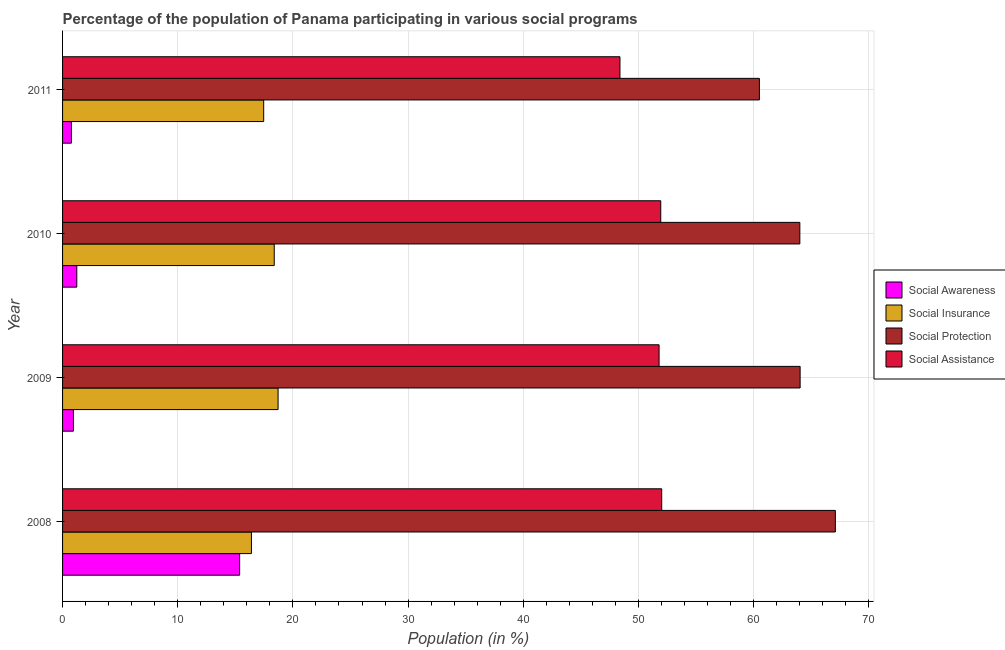How many different coloured bars are there?
Your answer should be very brief. 4. How many groups of bars are there?
Provide a succinct answer. 4. Are the number of bars per tick equal to the number of legend labels?
Provide a short and direct response. Yes. How many bars are there on the 3rd tick from the top?
Your answer should be compact. 4. How many bars are there on the 3rd tick from the bottom?
Provide a short and direct response. 4. In how many cases, is the number of bars for a given year not equal to the number of legend labels?
Ensure brevity in your answer.  0. What is the participation of population in social assistance programs in 2008?
Give a very brief answer. 52.02. Across all years, what is the maximum participation of population in social assistance programs?
Give a very brief answer. 52.02. Across all years, what is the minimum participation of population in social insurance programs?
Your answer should be very brief. 16.4. In which year was the participation of population in social insurance programs maximum?
Provide a short and direct response. 2009. In which year was the participation of population in social insurance programs minimum?
Offer a very short reply. 2008. What is the total participation of population in social awareness programs in the graph?
Your response must be concise. 18.32. What is the difference between the participation of population in social insurance programs in 2009 and that in 2011?
Offer a very short reply. 1.25. What is the difference between the participation of population in social awareness programs in 2009 and the participation of population in social assistance programs in 2011?
Offer a terse response. -47.45. What is the average participation of population in social insurance programs per year?
Ensure brevity in your answer.  17.74. In the year 2009, what is the difference between the participation of population in social insurance programs and participation of population in social assistance programs?
Your answer should be very brief. -33.08. In how many years, is the participation of population in social protection programs greater than 24 %?
Offer a very short reply. 4. Is the difference between the participation of population in social awareness programs in 2009 and 2011 greater than the difference between the participation of population in social protection programs in 2009 and 2011?
Offer a terse response. No. What is the difference between the highest and the second highest participation of population in social protection programs?
Your answer should be very brief. 3.06. What is the difference between the highest and the lowest participation of population in social assistance programs?
Your answer should be very brief. 3.62. In how many years, is the participation of population in social assistance programs greater than the average participation of population in social assistance programs taken over all years?
Offer a very short reply. 3. Is the sum of the participation of population in social awareness programs in 2008 and 2009 greater than the maximum participation of population in social insurance programs across all years?
Offer a very short reply. No. What does the 1st bar from the top in 2010 represents?
Provide a short and direct response. Social Assistance. What does the 3rd bar from the bottom in 2009 represents?
Your response must be concise. Social Protection. Are the values on the major ticks of X-axis written in scientific E-notation?
Make the answer very short. No. Does the graph contain any zero values?
Your answer should be very brief. No. Where does the legend appear in the graph?
Provide a succinct answer. Center right. How many legend labels are there?
Your answer should be compact. 4. What is the title of the graph?
Your response must be concise. Percentage of the population of Panama participating in various social programs . What is the label or title of the Y-axis?
Your answer should be compact. Year. What is the Population (in %) of Social Awareness in 2008?
Your answer should be very brief. 15.38. What is the Population (in %) of Social Insurance in 2008?
Your answer should be very brief. 16.4. What is the Population (in %) of Social Protection in 2008?
Keep it short and to the point. 67.1. What is the Population (in %) in Social Assistance in 2008?
Your answer should be compact. 52.02. What is the Population (in %) of Social Awareness in 2009?
Keep it short and to the point. 0.94. What is the Population (in %) in Social Insurance in 2009?
Offer a very short reply. 18.71. What is the Population (in %) in Social Protection in 2009?
Offer a very short reply. 64.04. What is the Population (in %) in Social Assistance in 2009?
Offer a terse response. 51.79. What is the Population (in %) in Social Awareness in 2010?
Your answer should be very brief. 1.24. What is the Population (in %) in Social Insurance in 2010?
Offer a very short reply. 18.38. What is the Population (in %) in Social Protection in 2010?
Ensure brevity in your answer.  64.02. What is the Population (in %) in Social Assistance in 2010?
Your response must be concise. 51.94. What is the Population (in %) in Social Awareness in 2011?
Keep it short and to the point. 0.77. What is the Population (in %) of Social Insurance in 2011?
Ensure brevity in your answer.  17.46. What is the Population (in %) in Social Protection in 2011?
Provide a short and direct response. 60.5. What is the Population (in %) of Social Assistance in 2011?
Provide a short and direct response. 48.4. Across all years, what is the maximum Population (in %) of Social Awareness?
Keep it short and to the point. 15.38. Across all years, what is the maximum Population (in %) of Social Insurance?
Your answer should be very brief. 18.71. Across all years, what is the maximum Population (in %) of Social Protection?
Your answer should be compact. 67.1. Across all years, what is the maximum Population (in %) of Social Assistance?
Your response must be concise. 52.02. Across all years, what is the minimum Population (in %) of Social Awareness?
Your answer should be compact. 0.77. Across all years, what is the minimum Population (in %) of Social Insurance?
Offer a terse response. 16.4. Across all years, what is the minimum Population (in %) of Social Protection?
Make the answer very short. 60.5. Across all years, what is the minimum Population (in %) in Social Assistance?
Offer a very short reply. 48.4. What is the total Population (in %) of Social Awareness in the graph?
Offer a very short reply. 18.32. What is the total Population (in %) in Social Insurance in the graph?
Give a very brief answer. 70.95. What is the total Population (in %) of Social Protection in the graph?
Keep it short and to the point. 255.66. What is the total Population (in %) in Social Assistance in the graph?
Make the answer very short. 204.15. What is the difference between the Population (in %) in Social Awareness in 2008 and that in 2009?
Make the answer very short. 14.43. What is the difference between the Population (in %) in Social Insurance in 2008 and that in 2009?
Ensure brevity in your answer.  -2.31. What is the difference between the Population (in %) of Social Protection in 2008 and that in 2009?
Offer a terse response. 3.06. What is the difference between the Population (in %) of Social Assistance in 2008 and that in 2009?
Make the answer very short. 0.23. What is the difference between the Population (in %) of Social Awareness in 2008 and that in 2010?
Your response must be concise. 14.14. What is the difference between the Population (in %) of Social Insurance in 2008 and that in 2010?
Offer a terse response. -1.98. What is the difference between the Population (in %) in Social Protection in 2008 and that in 2010?
Give a very brief answer. 3.08. What is the difference between the Population (in %) of Social Assistance in 2008 and that in 2010?
Keep it short and to the point. 0.08. What is the difference between the Population (in %) of Social Awareness in 2008 and that in 2011?
Offer a terse response. 14.61. What is the difference between the Population (in %) of Social Insurance in 2008 and that in 2011?
Offer a terse response. -1.06. What is the difference between the Population (in %) of Social Protection in 2008 and that in 2011?
Offer a terse response. 6.59. What is the difference between the Population (in %) in Social Assistance in 2008 and that in 2011?
Provide a short and direct response. 3.62. What is the difference between the Population (in %) of Social Awareness in 2009 and that in 2010?
Your response must be concise. -0.29. What is the difference between the Population (in %) in Social Insurance in 2009 and that in 2010?
Make the answer very short. 0.33. What is the difference between the Population (in %) in Social Protection in 2009 and that in 2010?
Your answer should be very brief. 0.02. What is the difference between the Population (in %) in Social Assistance in 2009 and that in 2010?
Give a very brief answer. -0.15. What is the difference between the Population (in %) of Social Awareness in 2009 and that in 2011?
Your response must be concise. 0.17. What is the difference between the Population (in %) in Social Insurance in 2009 and that in 2011?
Your answer should be compact. 1.25. What is the difference between the Population (in %) of Social Protection in 2009 and that in 2011?
Provide a short and direct response. 3.54. What is the difference between the Population (in %) in Social Assistance in 2009 and that in 2011?
Provide a succinct answer. 3.4. What is the difference between the Population (in %) in Social Awareness in 2010 and that in 2011?
Give a very brief answer. 0.47. What is the difference between the Population (in %) in Social Insurance in 2010 and that in 2011?
Keep it short and to the point. 0.92. What is the difference between the Population (in %) in Social Protection in 2010 and that in 2011?
Provide a short and direct response. 3.51. What is the difference between the Population (in %) in Social Assistance in 2010 and that in 2011?
Your answer should be very brief. 3.54. What is the difference between the Population (in %) of Social Awareness in 2008 and the Population (in %) of Social Insurance in 2009?
Your answer should be compact. -3.34. What is the difference between the Population (in %) in Social Awareness in 2008 and the Population (in %) in Social Protection in 2009?
Offer a terse response. -48.66. What is the difference between the Population (in %) in Social Awareness in 2008 and the Population (in %) in Social Assistance in 2009?
Keep it short and to the point. -36.42. What is the difference between the Population (in %) of Social Insurance in 2008 and the Population (in %) of Social Protection in 2009?
Your answer should be very brief. -47.64. What is the difference between the Population (in %) in Social Insurance in 2008 and the Population (in %) in Social Assistance in 2009?
Provide a short and direct response. -35.39. What is the difference between the Population (in %) in Social Protection in 2008 and the Population (in %) in Social Assistance in 2009?
Ensure brevity in your answer.  15.3. What is the difference between the Population (in %) in Social Awareness in 2008 and the Population (in %) in Social Insurance in 2010?
Give a very brief answer. -3. What is the difference between the Population (in %) in Social Awareness in 2008 and the Population (in %) in Social Protection in 2010?
Provide a short and direct response. -48.64. What is the difference between the Population (in %) of Social Awareness in 2008 and the Population (in %) of Social Assistance in 2010?
Your response must be concise. -36.56. What is the difference between the Population (in %) in Social Insurance in 2008 and the Population (in %) in Social Protection in 2010?
Provide a short and direct response. -47.62. What is the difference between the Population (in %) in Social Insurance in 2008 and the Population (in %) in Social Assistance in 2010?
Provide a succinct answer. -35.54. What is the difference between the Population (in %) in Social Protection in 2008 and the Population (in %) in Social Assistance in 2010?
Make the answer very short. 15.16. What is the difference between the Population (in %) in Social Awareness in 2008 and the Population (in %) in Social Insurance in 2011?
Your answer should be compact. -2.09. What is the difference between the Population (in %) in Social Awareness in 2008 and the Population (in %) in Social Protection in 2011?
Your response must be concise. -45.13. What is the difference between the Population (in %) of Social Awareness in 2008 and the Population (in %) of Social Assistance in 2011?
Keep it short and to the point. -33.02. What is the difference between the Population (in %) of Social Insurance in 2008 and the Population (in %) of Social Protection in 2011?
Offer a terse response. -44.1. What is the difference between the Population (in %) in Social Insurance in 2008 and the Population (in %) in Social Assistance in 2011?
Offer a very short reply. -32. What is the difference between the Population (in %) in Social Protection in 2008 and the Population (in %) in Social Assistance in 2011?
Provide a succinct answer. 18.7. What is the difference between the Population (in %) in Social Awareness in 2009 and the Population (in %) in Social Insurance in 2010?
Keep it short and to the point. -17.44. What is the difference between the Population (in %) in Social Awareness in 2009 and the Population (in %) in Social Protection in 2010?
Your response must be concise. -63.07. What is the difference between the Population (in %) of Social Awareness in 2009 and the Population (in %) of Social Assistance in 2010?
Ensure brevity in your answer.  -51. What is the difference between the Population (in %) in Social Insurance in 2009 and the Population (in %) in Social Protection in 2010?
Give a very brief answer. -45.3. What is the difference between the Population (in %) of Social Insurance in 2009 and the Population (in %) of Social Assistance in 2010?
Your answer should be compact. -33.23. What is the difference between the Population (in %) of Social Protection in 2009 and the Population (in %) of Social Assistance in 2010?
Your answer should be compact. 12.1. What is the difference between the Population (in %) in Social Awareness in 2009 and the Population (in %) in Social Insurance in 2011?
Provide a succinct answer. -16.52. What is the difference between the Population (in %) in Social Awareness in 2009 and the Population (in %) in Social Protection in 2011?
Your answer should be compact. -59.56. What is the difference between the Population (in %) in Social Awareness in 2009 and the Population (in %) in Social Assistance in 2011?
Offer a very short reply. -47.45. What is the difference between the Population (in %) in Social Insurance in 2009 and the Population (in %) in Social Protection in 2011?
Your answer should be compact. -41.79. What is the difference between the Population (in %) in Social Insurance in 2009 and the Population (in %) in Social Assistance in 2011?
Offer a very short reply. -29.68. What is the difference between the Population (in %) in Social Protection in 2009 and the Population (in %) in Social Assistance in 2011?
Provide a succinct answer. 15.64. What is the difference between the Population (in %) in Social Awareness in 2010 and the Population (in %) in Social Insurance in 2011?
Provide a succinct answer. -16.23. What is the difference between the Population (in %) in Social Awareness in 2010 and the Population (in %) in Social Protection in 2011?
Your answer should be compact. -59.27. What is the difference between the Population (in %) in Social Awareness in 2010 and the Population (in %) in Social Assistance in 2011?
Offer a very short reply. -47.16. What is the difference between the Population (in %) in Social Insurance in 2010 and the Population (in %) in Social Protection in 2011?
Provide a short and direct response. -42.12. What is the difference between the Population (in %) of Social Insurance in 2010 and the Population (in %) of Social Assistance in 2011?
Provide a succinct answer. -30.02. What is the difference between the Population (in %) in Social Protection in 2010 and the Population (in %) in Social Assistance in 2011?
Give a very brief answer. 15.62. What is the average Population (in %) in Social Awareness per year?
Your response must be concise. 4.58. What is the average Population (in %) in Social Insurance per year?
Give a very brief answer. 17.74. What is the average Population (in %) in Social Protection per year?
Provide a succinct answer. 63.91. What is the average Population (in %) in Social Assistance per year?
Offer a very short reply. 51.04. In the year 2008, what is the difference between the Population (in %) in Social Awareness and Population (in %) in Social Insurance?
Offer a terse response. -1.02. In the year 2008, what is the difference between the Population (in %) of Social Awareness and Population (in %) of Social Protection?
Your answer should be compact. -51.72. In the year 2008, what is the difference between the Population (in %) of Social Awareness and Population (in %) of Social Assistance?
Your response must be concise. -36.65. In the year 2008, what is the difference between the Population (in %) in Social Insurance and Population (in %) in Social Protection?
Your answer should be compact. -50.7. In the year 2008, what is the difference between the Population (in %) of Social Insurance and Population (in %) of Social Assistance?
Ensure brevity in your answer.  -35.62. In the year 2008, what is the difference between the Population (in %) in Social Protection and Population (in %) in Social Assistance?
Make the answer very short. 15.08. In the year 2009, what is the difference between the Population (in %) of Social Awareness and Population (in %) of Social Insurance?
Provide a short and direct response. -17.77. In the year 2009, what is the difference between the Population (in %) in Social Awareness and Population (in %) in Social Protection?
Provide a short and direct response. -63.1. In the year 2009, what is the difference between the Population (in %) of Social Awareness and Population (in %) of Social Assistance?
Your response must be concise. -50.85. In the year 2009, what is the difference between the Population (in %) in Social Insurance and Population (in %) in Social Protection?
Offer a very short reply. -45.33. In the year 2009, what is the difference between the Population (in %) in Social Insurance and Population (in %) in Social Assistance?
Make the answer very short. -33.08. In the year 2009, what is the difference between the Population (in %) of Social Protection and Population (in %) of Social Assistance?
Keep it short and to the point. 12.25. In the year 2010, what is the difference between the Population (in %) in Social Awareness and Population (in %) in Social Insurance?
Give a very brief answer. -17.14. In the year 2010, what is the difference between the Population (in %) of Social Awareness and Population (in %) of Social Protection?
Your response must be concise. -62.78. In the year 2010, what is the difference between the Population (in %) in Social Awareness and Population (in %) in Social Assistance?
Your answer should be very brief. -50.7. In the year 2010, what is the difference between the Population (in %) in Social Insurance and Population (in %) in Social Protection?
Keep it short and to the point. -45.64. In the year 2010, what is the difference between the Population (in %) in Social Insurance and Population (in %) in Social Assistance?
Provide a short and direct response. -33.56. In the year 2010, what is the difference between the Population (in %) in Social Protection and Population (in %) in Social Assistance?
Keep it short and to the point. 12.08. In the year 2011, what is the difference between the Population (in %) in Social Awareness and Population (in %) in Social Insurance?
Give a very brief answer. -16.7. In the year 2011, what is the difference between the Population (in %) in Social Awareness and Population (in %) in Social Protection?
Give a very brief answer. -59.74. In the year 2011, what is the difference between the Population (in %) in Social Awareness and Population (in %) in Social Assistance?
Provide a succinct answer. -47.63. In the year 2011, what is the difference between the Population (in %) of Social Insurance and Population (in %) of Social Protection?
Offer a terse response. -43.04. In the year 2011, what is the difference between the Population (in %) of Social Insurance and Population (in %) of Social Assistance?
Your answer should be very brief. -30.93. In the year 2011, what is the difference between the Population (in %) of Social Protection and Population (in %) of Social Assistance?
Ensure brevity in your answer.  12.11. What is the ratio of the Population (in %) in Social Awareness in 2008 to that in 2009?
Provide a succinct answer. 16.32. What is the ratio of the Population (in %) in Social Insurance in 2008 to that in 2009?
Your answer should be very brief. 0.88. What is the ratio of the Population (in %) in Social Protection in 2008 to that in 2009?
Keep it short and to the point. 1.05. What is the ratio of the Population (in %) of Social Awareness in 2008 to that in 2010?
Your answer should be compact. 12.44. What is the ratio of the Population (in %) of Social Insurance in 2008 to that in 2010?
Your answer should be very brief. 0.89. What is the ratio of the Population (in %) of Social Protection in 2008 to that in 2010?
Make the answer very short. 1.05. What is the ratio of the Population (in %) in Social Assistance in 2008 to that in 2010?
Keep it short and to the point. 1. What is the ratio of the Population (in %) in Social Awareness in 2008 to that in 2011?
Offer a terse response. 20.04. What is the ratio of the Population (in %) of Social Insurance in 2008 to that in 2011?
Give a very brief answer. 0.94. What is the ratio of the Population (in %) in Social Protection in 2008 to that in 2011?
Make the answer very short. 1.11. What is the ratio of the Population (in %) of Social Assistance in 2008 to that in 2011?
Ensure brevity in your answer.  1.07. What is the ratio of the Population (in %) in Social Awareness in 2009 to that in 2010?
Offer a terse response. 0.76. What is the ratio of the Population (in %) in Social Insurance in 2009 to that in 2010?
Your response must be concise. 1.02. What is the ratio of the Population (in %) in Social Assistance in 2009 to that in 2010?
Provide a short and direct response. 1. What is the ratio of the Population (in %) of Social Awareness in 2009 to that in 2011?
Your answer should be very brief. 1.23. What is the ratio of the Population (in %) of Social Insurance in 2009 to that in 2011?
Ensure brevity in your answer.  1.07. What is the ratio of the Population (in %) of Social Protection in 2009 to that in 2011?
Ensure brevity in your answer.  1.06. What is the ratio of the Population (in %) of Social Assistance in 2009 to that in 2011?
Provide a succinct answer. 1.07. What is the ratio of the Population (in %) of Social Awareness in 2010 to that in 2011?
Provide a short and direct response. 1.61. What is the ratio of the Population (in %) in Social Insurance in 2010 to that in 2011?
Your response must be concise. 1.05. What is the ratio of the Population (in %) in Social Protection in 2010 to that in 2011?
Provide a short and direct response. 1.06. What is the ratio of the Population (in %) in Social Assistance in 2010 to that in 2011?
Offer a very short reply. 1.07. What is the difference between the highest and the second highest Population (in %) of Social Awareness?
Your response must be concise. 14.14. What is the difference between the highest and the second highest Population (in %) of Social Insurance?
Make the answer very short. 0.33. What is the difference between the highest and the second highest Population (in %) in Social Protection?
Provide a succinct answer. 3.06. What is the difference between the highest and the second highest Population (in %) in Social Assistance?
Offer a terse response. 0.08. What is the difference between the highest and the lowest Population (in %) of Social Awareness?
Your answer should be compact. 14.61. What is the difference between the highest and the lowest Population (in %) in Social Insurance?
Your response must be concise. 2.31. What is the difference between the highest and the lowest Population (in %) in Social Protection?
Offer a terse response. 6.59. What is the difference between the highest and the lowest Population (in %) of Social Assistance?
Give a very brief answer. 3.62. 